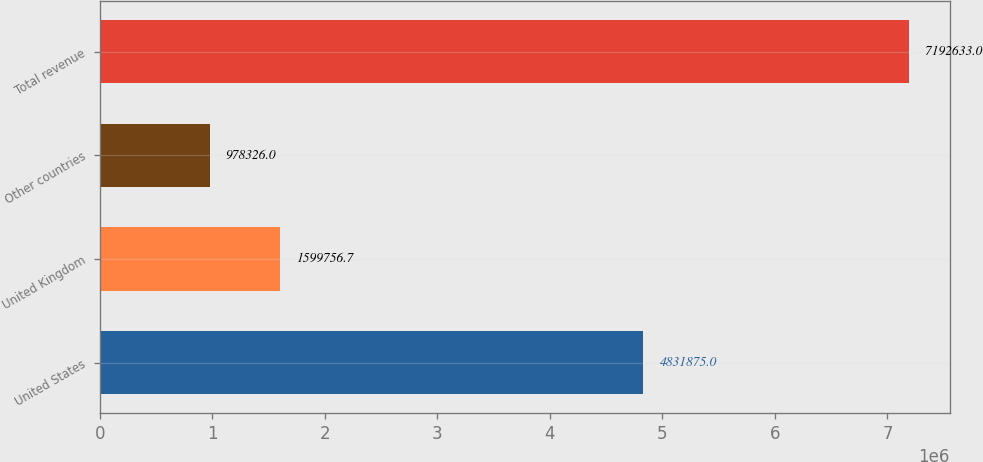Convert chart. <chart><loc_0><loc_0><loc_500><loc_500><bar_chart><fcel>United States<fcel>United Kingdom<fcel>Other countries<fcel>Total revenue<nl><fcel>4.83188e+06<fcel>1.59976e+06<fcel>978326<fcel>7.19263e+06<nl></chart> 